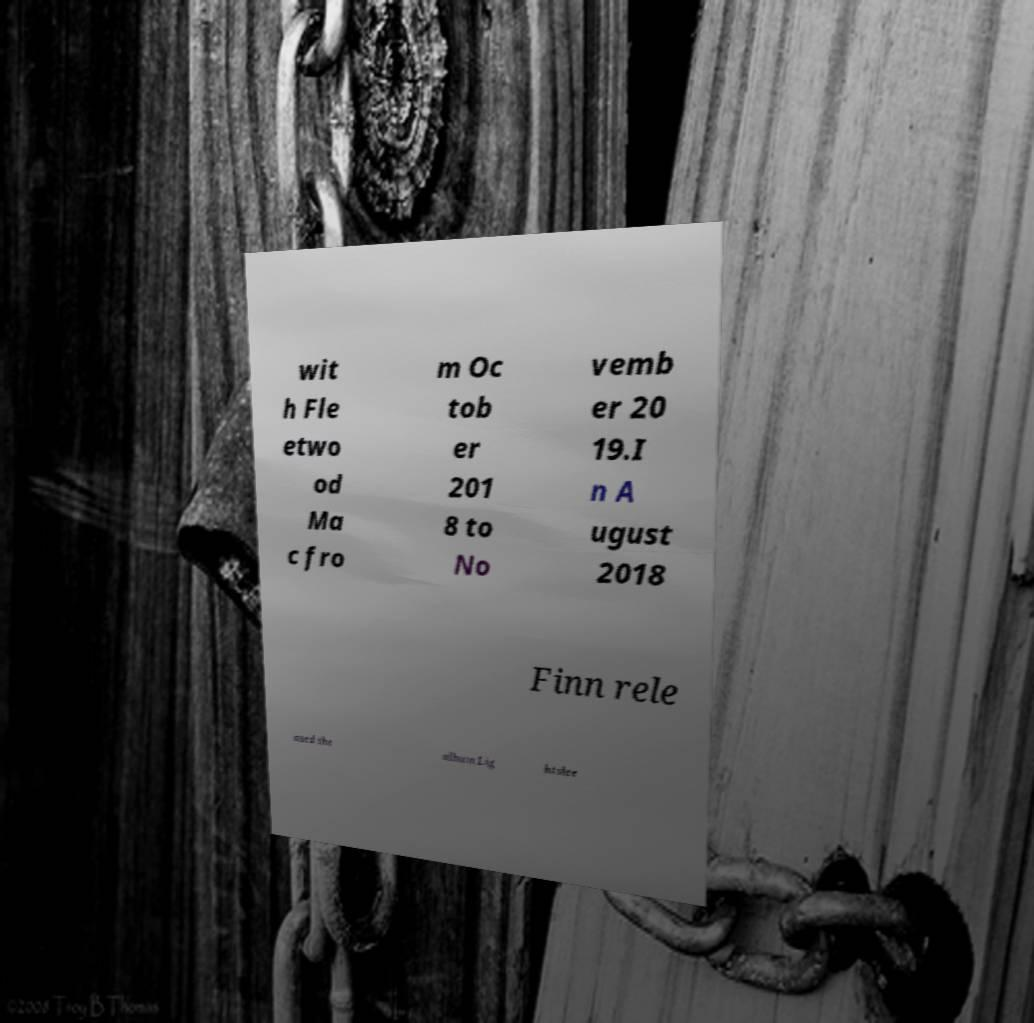Please identify and transcribe the text found in this image. wit h Fle etwo od Ma c fro m Oc tob er 201 8 to No vemb er 20 19.I n A ugust 2018 Finn rele ased the album Lig htslee 